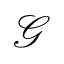<formula> <loc_0><loc_0><loc_500><loc_500>\mathcal { G }</formula> 